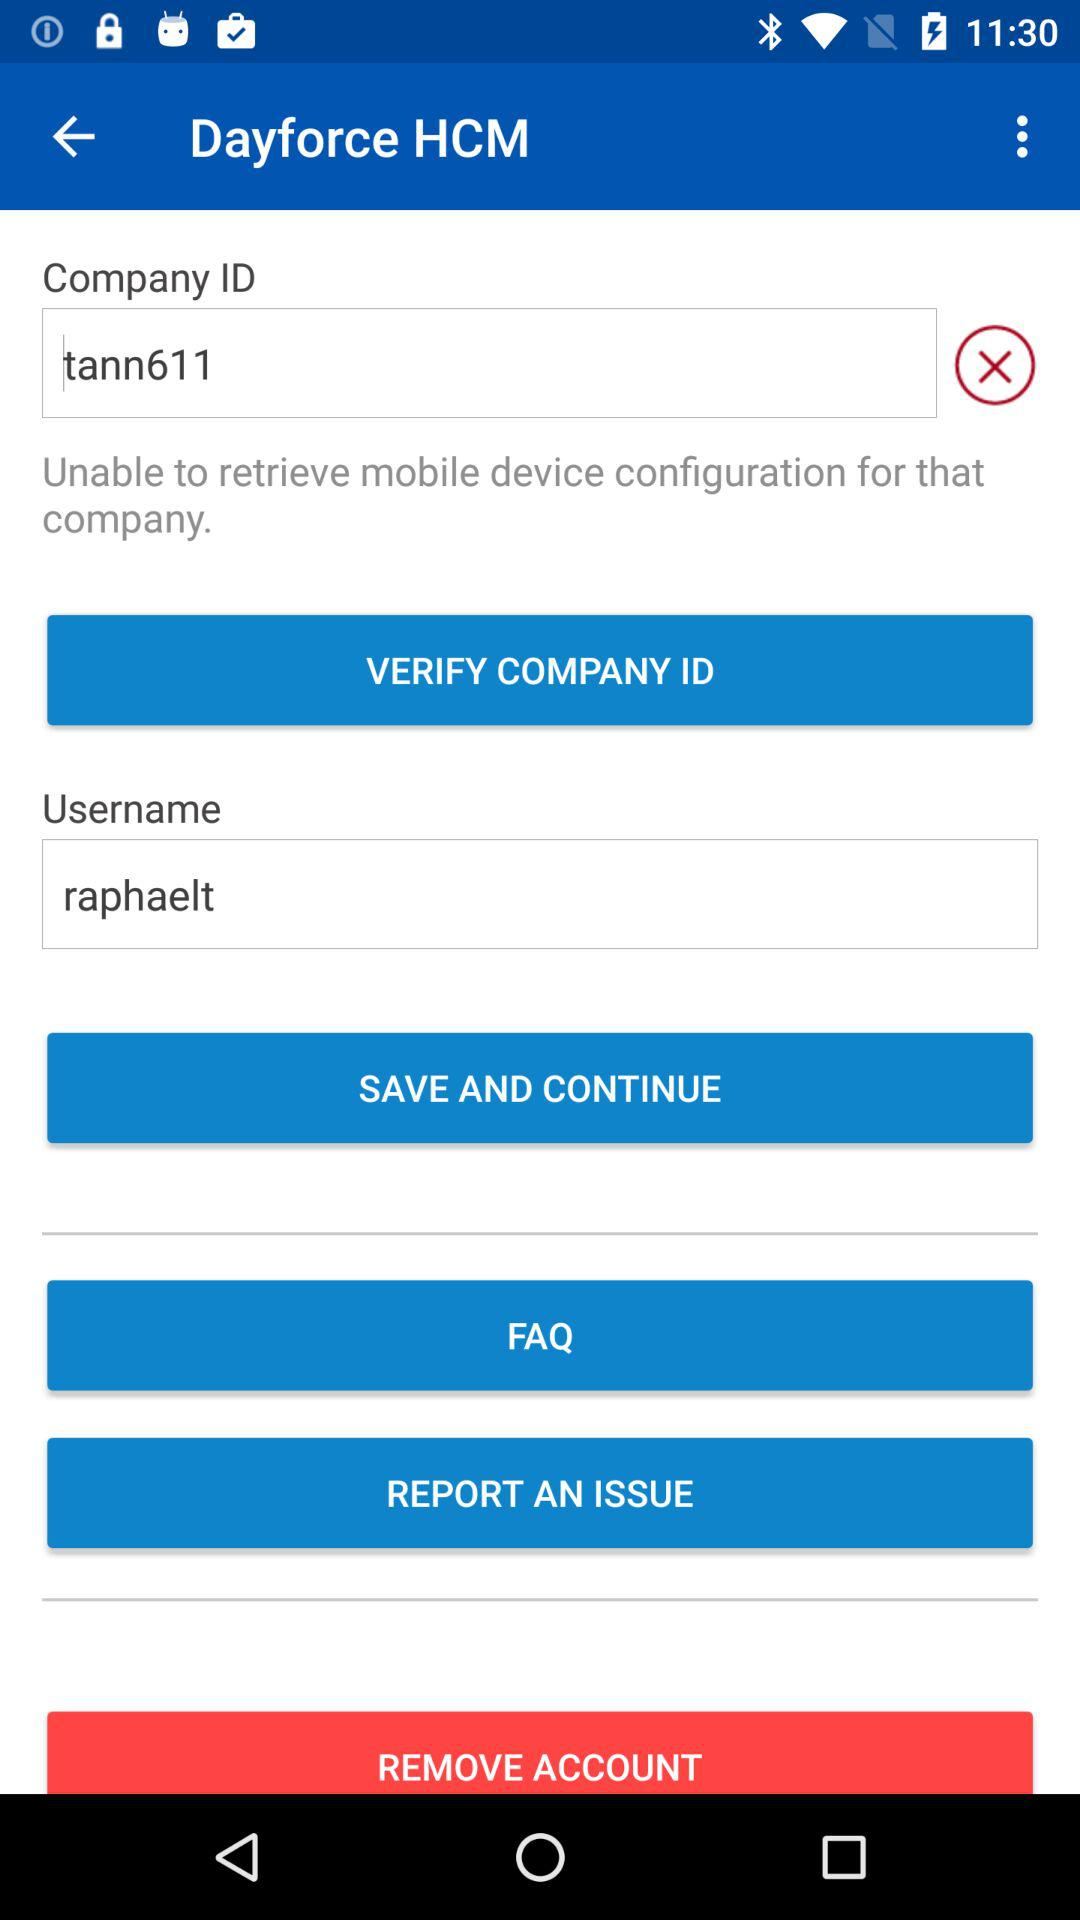What is the username? The username is "raphaelt". 